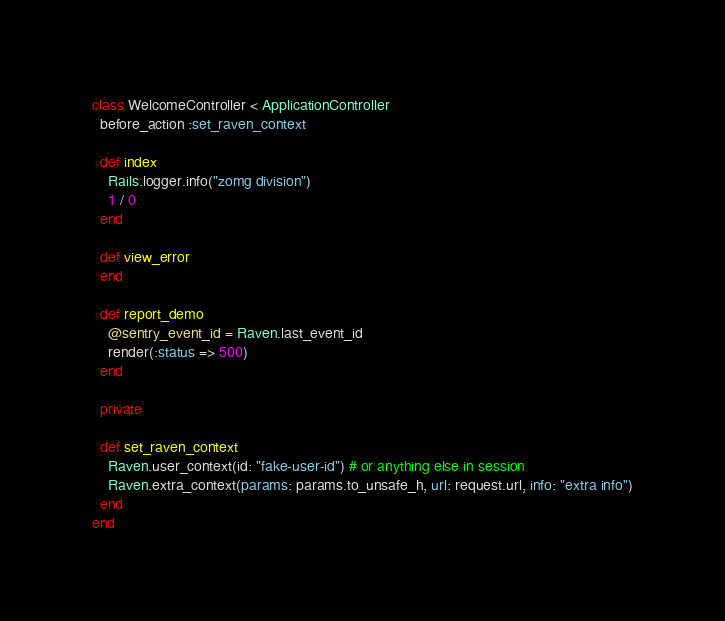Convert code to text. <code><loc_0><loc_0><loc_500><loc_500><_Ruby_>class WelcomeController < ApplicationController
  before_action :set_raven_context

  def index
    Rails.logger.info("zomg division")
    1 / 0
  end

  def view_error
  end

  def report_demo
    @sentry_event_id = Raven.last_event_id
    render(:status => 500)
  end

  private

  def set_raven_context
    Raven.user_context(id: "fake-user-id") # or anything else in session
    Raven.extra_context(params: params.to_unsafe_h, url: request.url, info: "extra info")
  end
end
</code> 